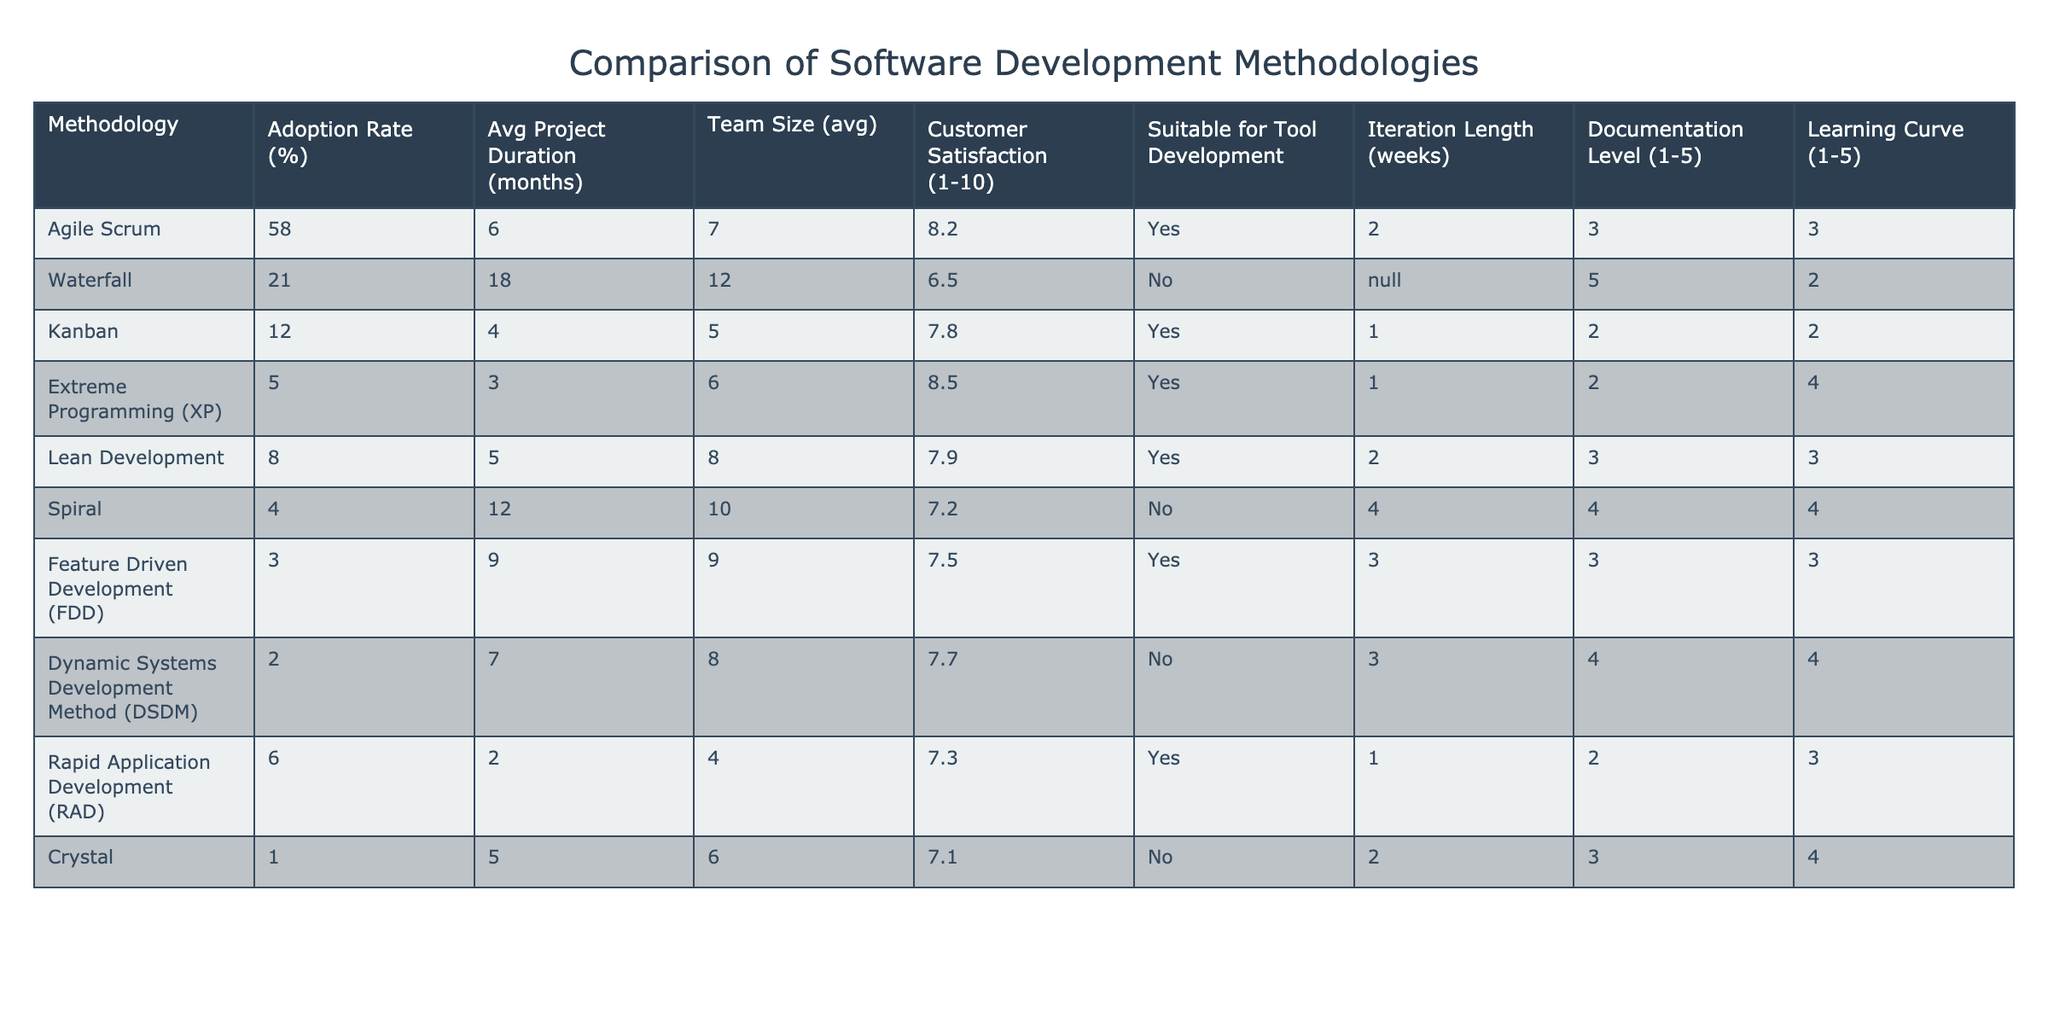What's the adoption rate of Agile Scrum? The table shows that Agile Scrum has an adoption rate of 58%.
Answer: 58% Which methodology has the highest customer satisfaction rating? According to the table, Extreme Programming (XP) has the highest customer satisfaction rating at 8.5.
Answer: Extreme Programming (XP) What is the average project duration for the Waterfall methodology? The table specifies that the average project duration for the Waterfall methodology is 18 months.
Answer: 18 months How many methodologies have an adoption rate of less than 10%? The methodologies with an adoption rate of less than 10% are Spiral, Feature Driven Development (FDD), Dynamic Systems Development Method (DSDM), and Crystal, totaling four methodologies.
Answer: 4 Is documentation level higher for Agile Scrum than for Kanban? The documentation level for Agile Scrum is 3, while for Kanban it is 2; thus, the documentation level is indeed higher for Agile Scrum.
Answer: Yes What is the average team size for methodologies that are suitable for tool development? The suitable methodologies for tool development are Agile Scrum, Kanban, Extreme Programming (XP), Lean Development, and Rapid Application Development (RAD). Their team sizes are 7, 5, 6, 8, and 4 respectively. Summing these gives 30, and averaging over 5 provides 30/5 = 6.
Answer: 6 Which methodology has the lowest iteration length and what is that length? The methodology with the lowest iteration length is Kanban, with an iteration length of 1 week.
Answer: 1 week What is the difference in customer satisfaction between Waterfall and Agile Scrum? Agile Scrum has a customer satisfaction rating of 8.2, while Waterfall has a rating of 6.5. The difference is 8.2 - 6.5 = 1.7.
Answer: 1.7 Are there any methodologies that have an average project duration of less than 5 months? By examining the table, only the Rapid Application Development (RAD) methodology has an average project duration of 2 months, which confirms that there is at least one methodology that meets this criterion.
Answer: Yes What is the highest documentation level among the methodologies, and which one has it? The highest documentation level is 5, which is associated with the Waterfall methodology.
Answer: Waterfall, 5 